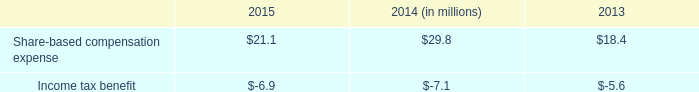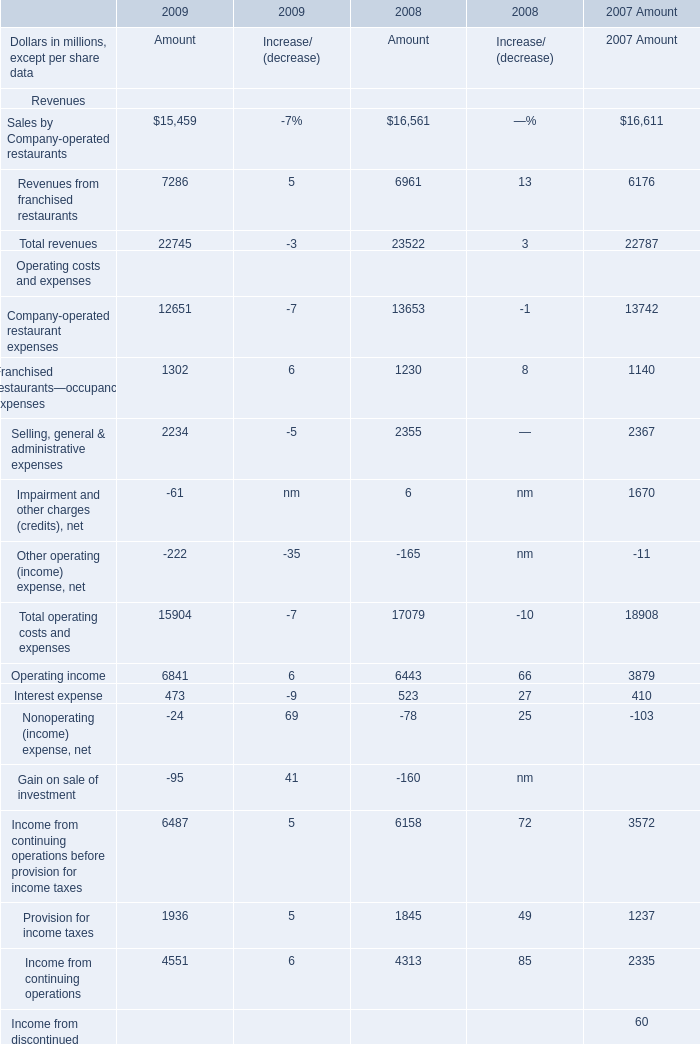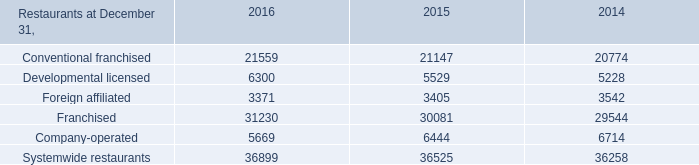What's the average of Systemwide restaurants of 2014, and Operating income Operating costs and expenses of 2007 Amount ? 
Computations: ((36258.0 + 3879.0) / 2)
Answer: 20068.5. 